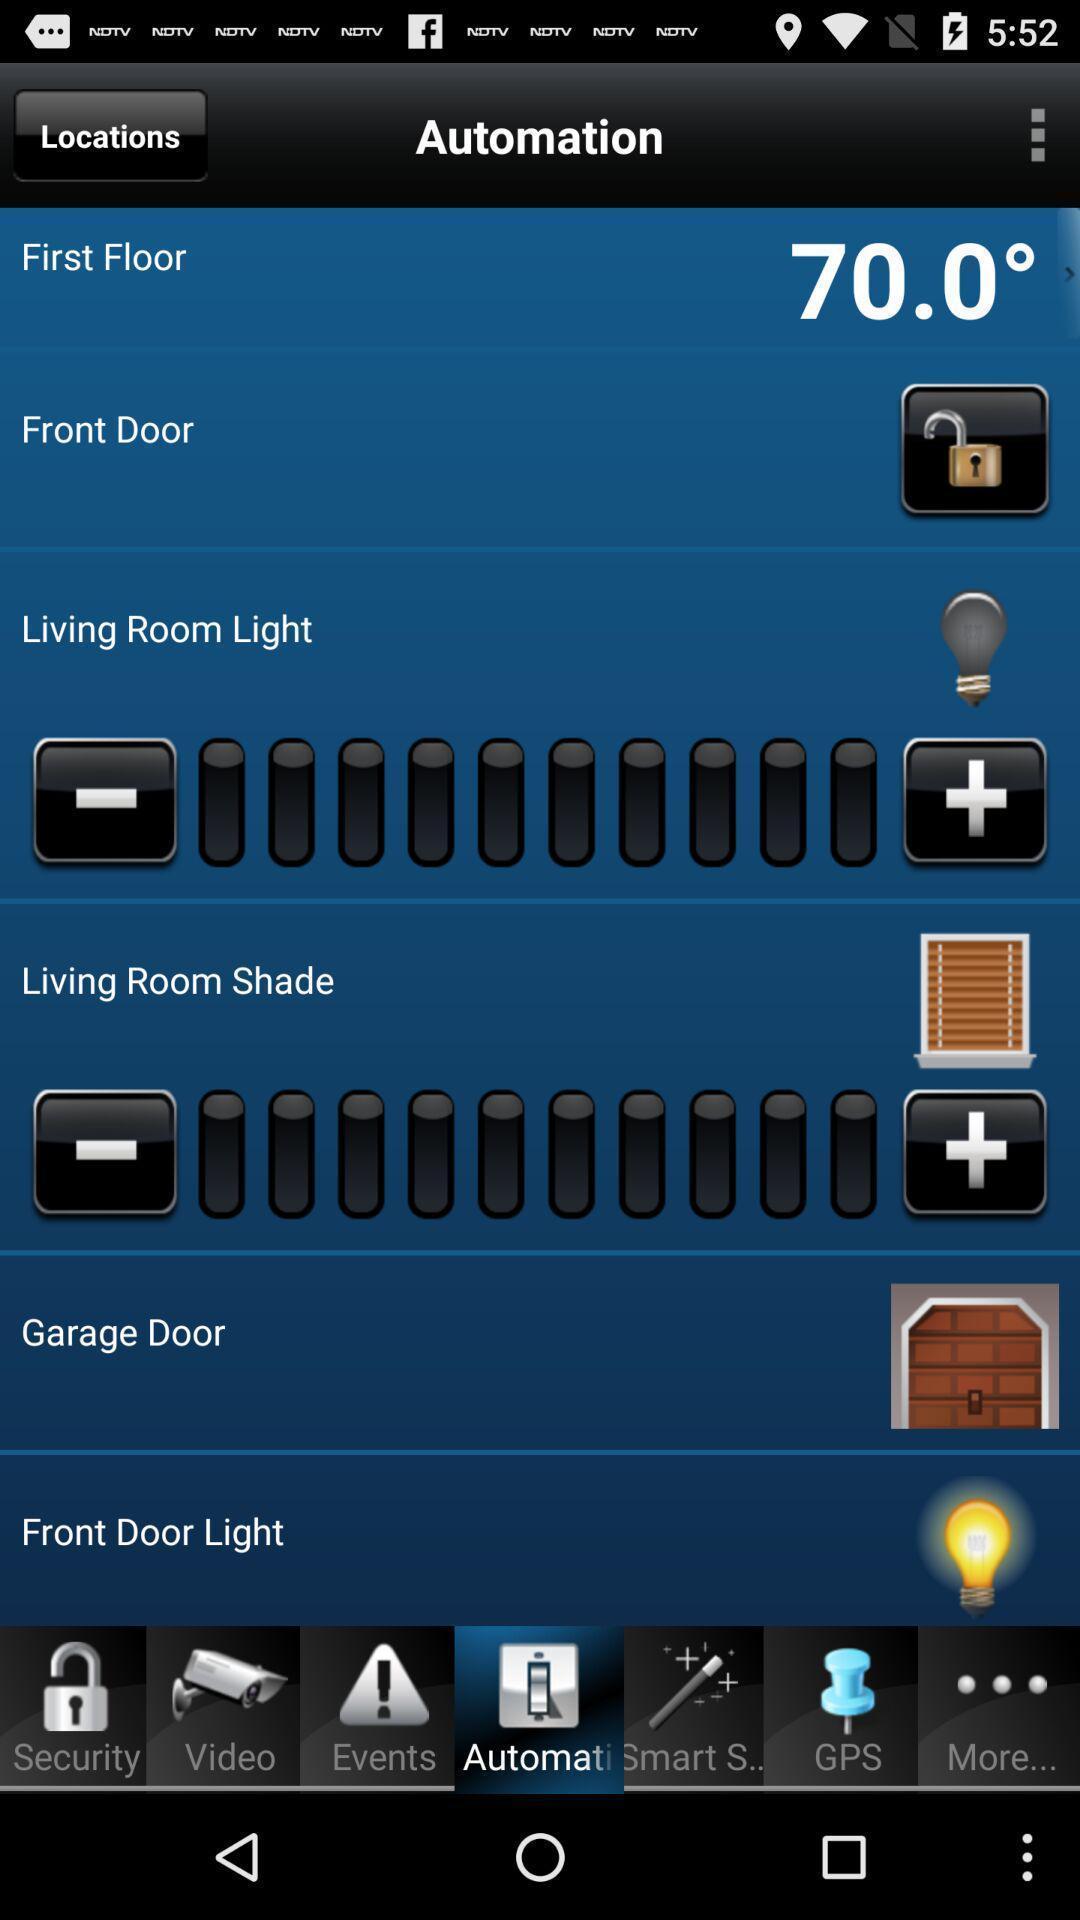Explain the elements present in this screenshot. Various options. 